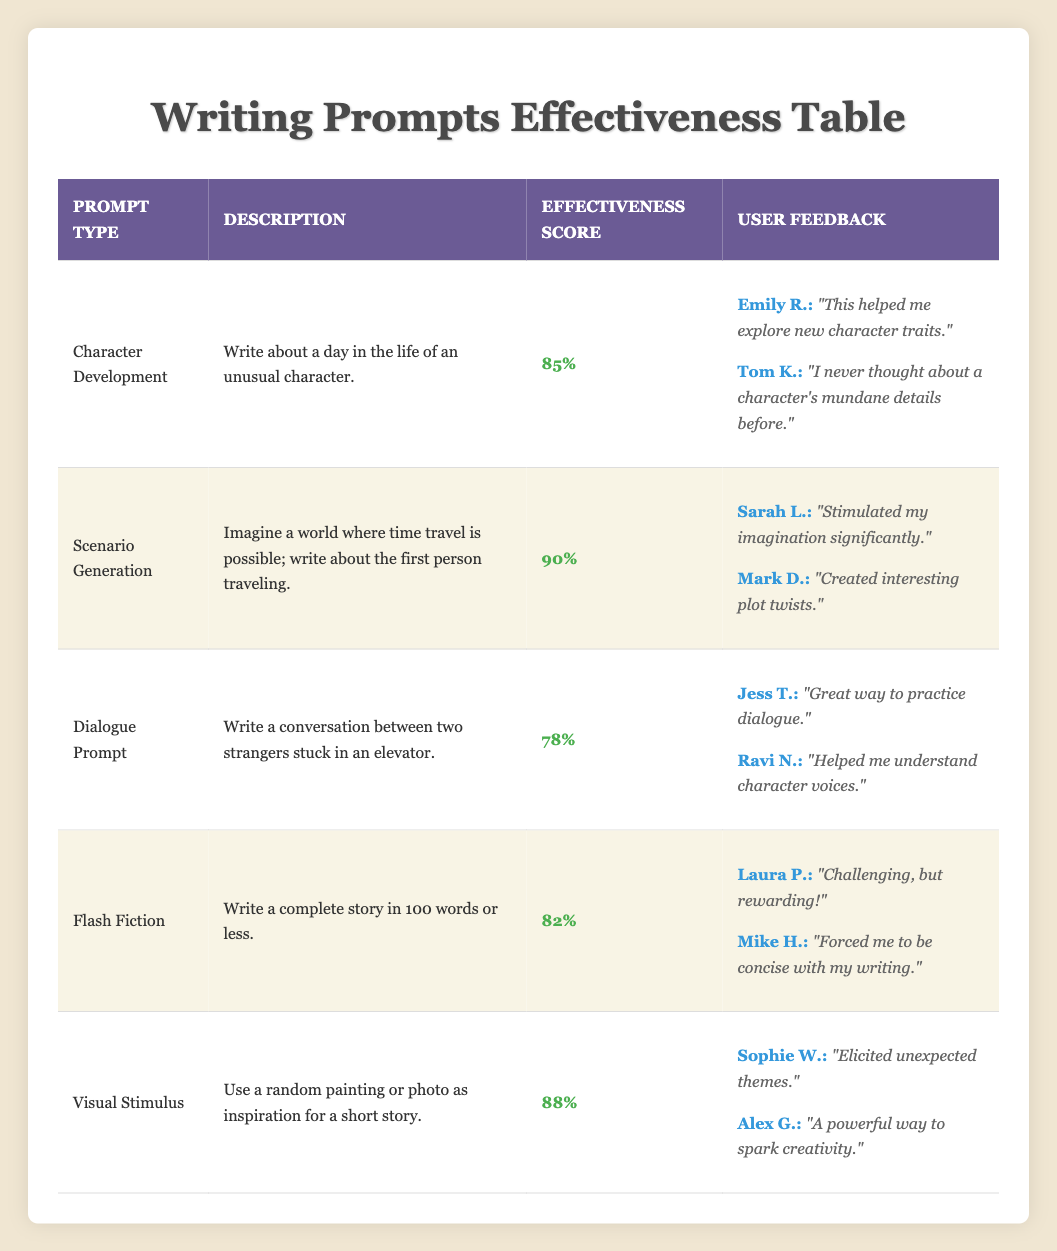What is the effectiveness score of Scenario Generation? The effectiveness score for Scenario Generation can be found in the table under the "Effectiveness Score" column next to the prompt type. It shows a score of 90%.
Answer: 90% Which prompt type has the highest effectiveness score? By comparing all effectiveness scores listed in the table, Scenario Generation has the highest score of 90%, making it the most effective writing prompt.
Answer: Scenario Generation How many prompts have an effectiveness score above 85? The table lists five prompts. Among these, Scenario Generation (90), Visual Stimulus (88), and Character Development (85) scores above 85. That's three prompts in total.
Answer: 3 Is it true that Dialogue Prompt has the lowest effectiveness score? Looking at the effectiveness scores, Dialogue Prompt has a score of 78%, which is lower than the other prompts listed. Therefore, it is true.
Answer: Yes What is the average effectiveness score of the prompts listed? First, we add the scores together: (85 + 90 + 78 + 82 + 88) = 423. Then, divide by the number of prompts (5), resulting in an average score of 423 / 5 = 84.6.
Answer: 84.6 What user mentioned that the Visual Stimulus prompt helped them spark creativity? The user feedback for Visual Stimulus shows comments from Sophie W. and Alex G. The specific feedback mentioning sparking creativity comes from Alex G.
Answer: Alex G Which prompt generated feedback regarding understanding character voices? The Dialogue Prompt column contains user feedback from Ravi N., who commented that it helped him understand character voices.
Answer: Dialogue Prompt What is the total number of users who provided feedback on all prompts listed? Counting the users from the feedback for each prompt: 2 users for Character Development, 2 for Scenario Generation, 2 for Dialogue Prompt, 2 for Flash Fiction, and 2 for Visual Stimulus, resulting in a total of 10 users.
Answer: 10 Which two prompts are more effective than 80% according to the table? By examining effectiveness scores, Scenario Generation (90) and Visual Stimulus (88) are both above 80%.
Answer: Scenario Generation, Visual Stimulus 